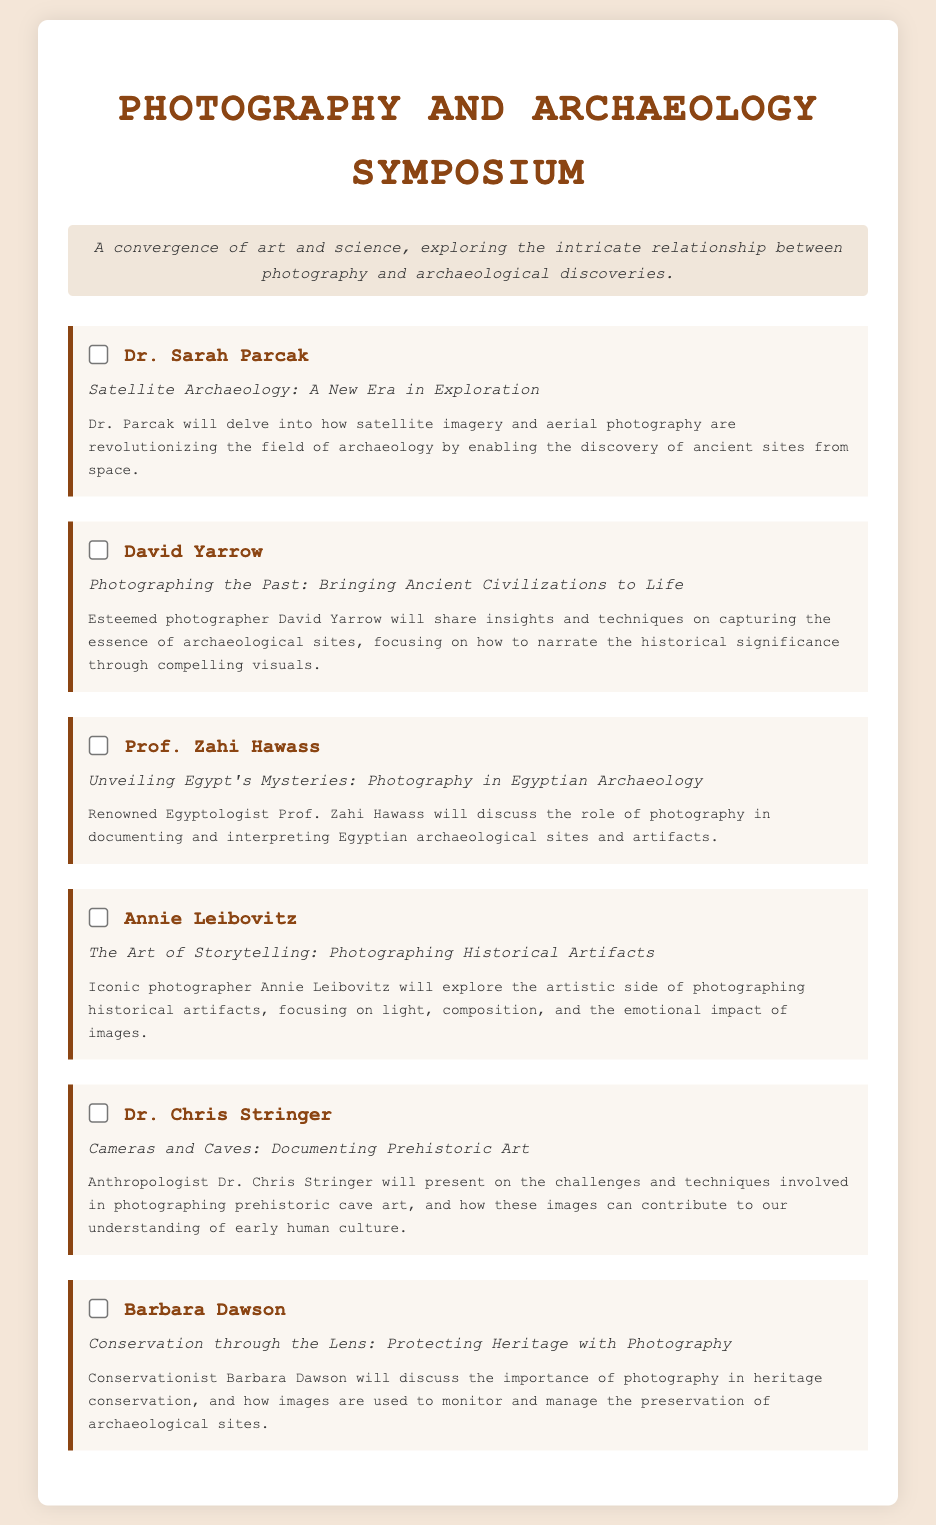What is the title of the symposium? The title of the symposium is prominently displayed at the top of the document.
Answer: Photography and Archaeology Symposium Who is presenting the topic on "Satellite Archaeology"? The speaker for "Satellite Archaeology: A New Era in Exploration" is listed with their name.
Answer: Dr. Sarah Parcak How many speakers are mentioned in the document? The document lists a total of six speakers, each accompanied by a topic.
Answer: 6 What is the main focus of David Yarrow's presentation? The description of David Yarrow's presentation indicates its emphasis.
Answer: Capturing the essence of archaeological sites Which speaker focuses on the topic of cave art? The specific speaker related to photographing prehistoric cave art can be found in their description.
Answer: Dr. Chris Stringer What unique perspective does Annie Leibovitz bring to the symposium? The document describes Annie Leibovitz's focus in her presentation.
Answer: The artistic side of photographing historical artifacts What is Barbara Dawson's area of discussion? The description details Barbara Dawson's focus on a particular theme related to photography.
Answer: Heritage conservation List one method mentioned by Dr. Chris Stringer for documenting art. The document highlights a specific aspect of Dr. Stringer's presentation related to the challenges and techniques used.
Answer: Photographing prehistoric cave art 